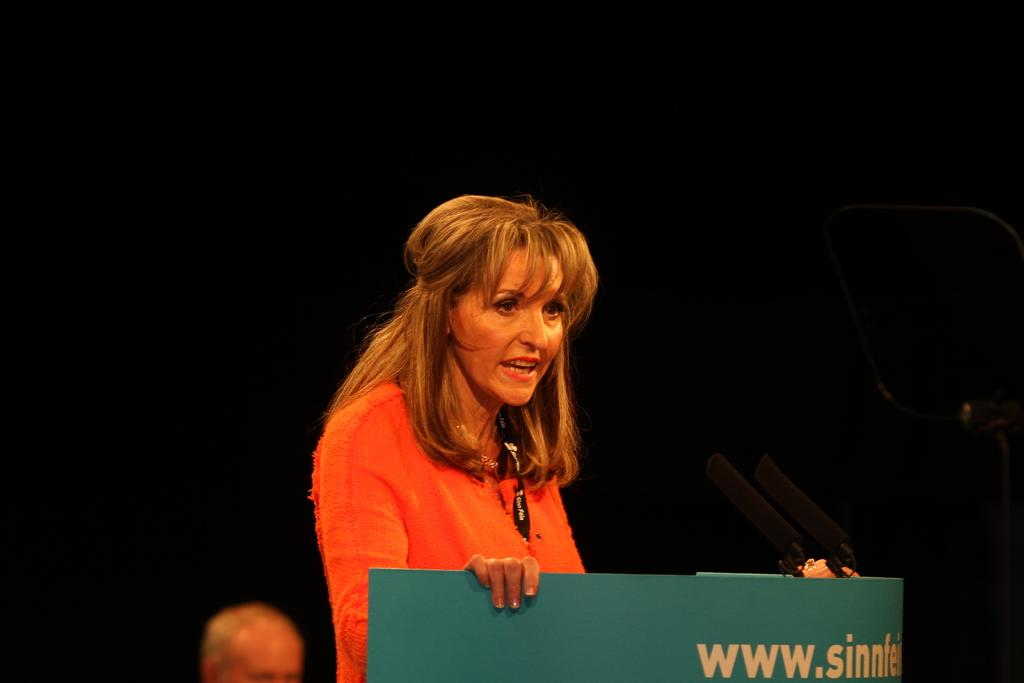How many people are in the foreground of the image? There are two persons in the foreground of the image. What is located behind the two persons? The two persons are in front of a table. What objects can be seen on the table? There are microphones (mike's) in the image. What is the color of the background in the image? The background of the image is dark in color. Where might this image have been taken? The image may have been taken on a stage. How many lizards are crawling on the table in the image? There are no lizards present in the image; the objects on the table are microphones. What type of footwear is the person on the left wearing in the image? The image does not show the feet or footwear of the persons in the foreground. 